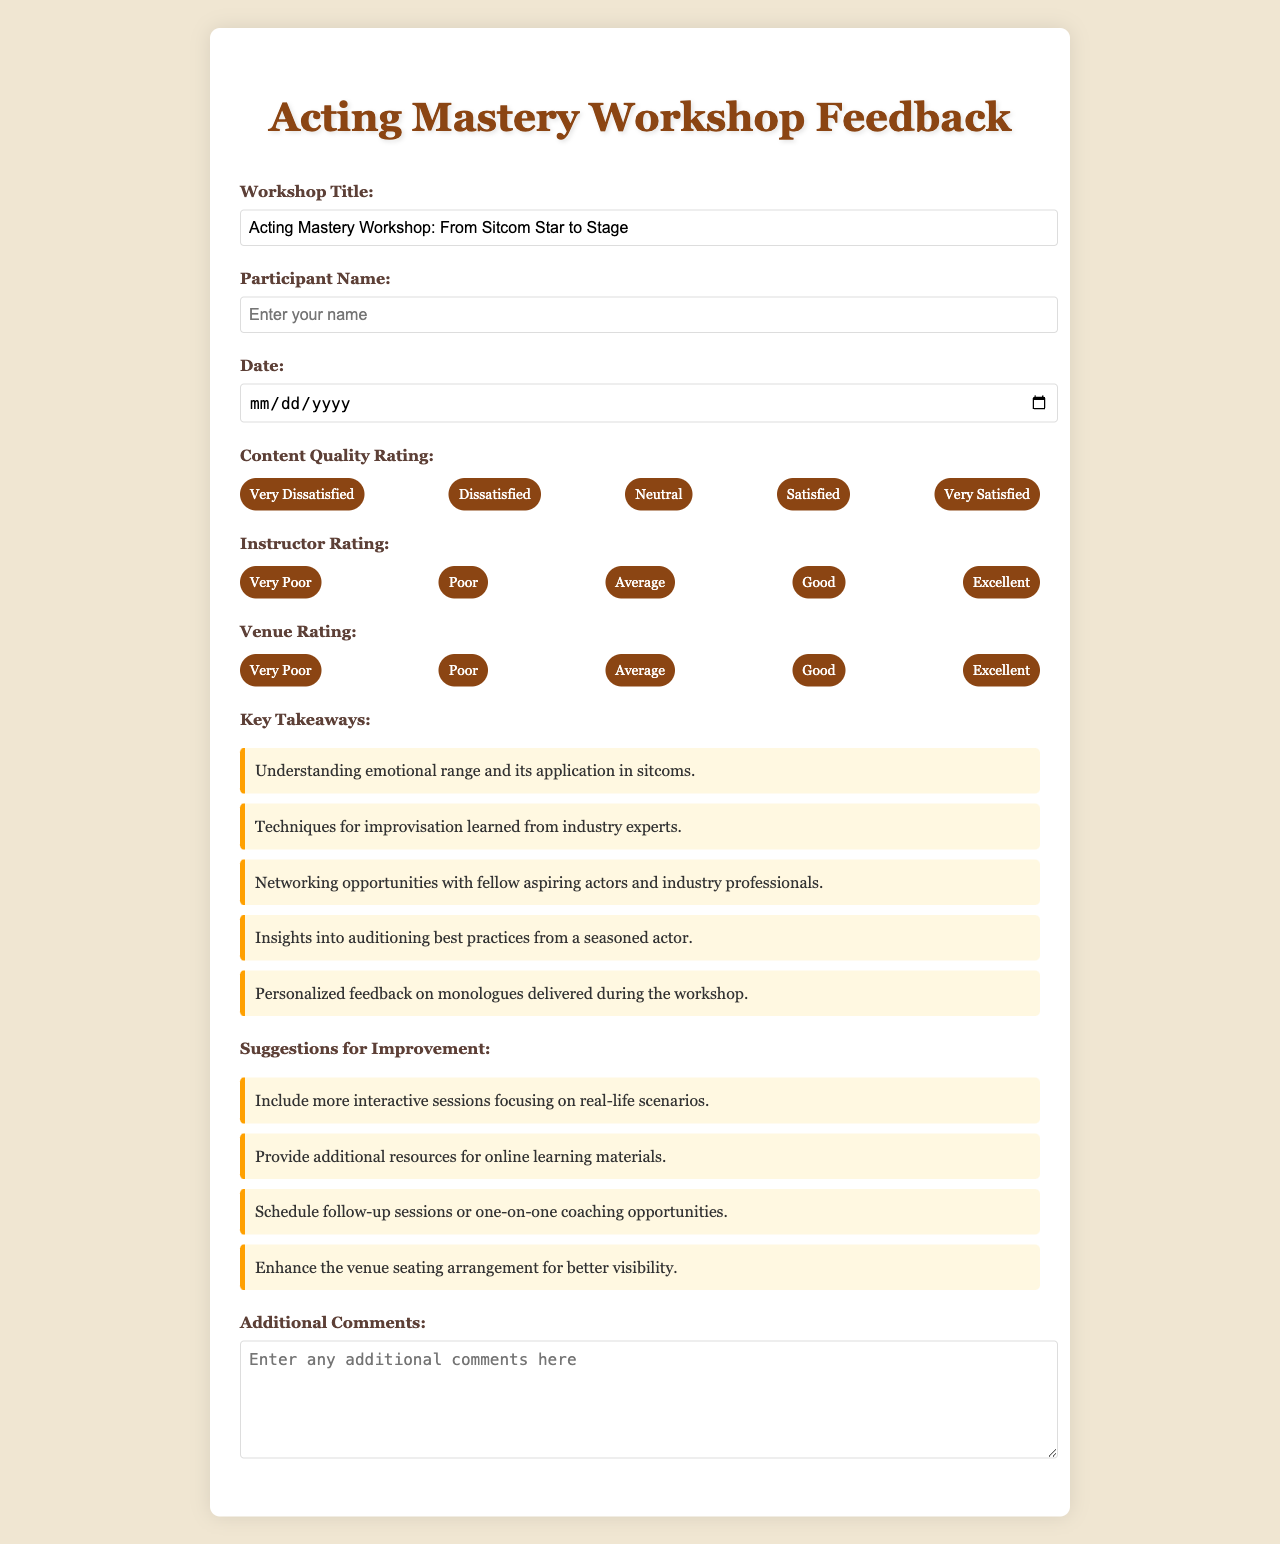What is the title of the workshop? The title is provided in the document, which states "Workshop Title: Acting Mastery Workshop: From Sitcom Star to Stage".
Answer: Acting Mastery Workshop: From Sitcom Star to Stage What is the main topic of the key takeaways? The key takeaways are listed in a section focused on insights gained from the workshop, including various skills and networking.
Answer: Understanding emotional range and its application in sitcoms How many suggestions for improvement are provided? The number of suggestions can be counted in the document, which lists four distinct ideas for improvement.
Answer: Four What rating is given for the content quality? There is a section titled "Content Quality Rating" with multiple options indicating the satisfaction level, but no specific rating is provided in the text.
Answer: Not specified What is the date field in the form used for? The date field is included in the form for participants to input when they attended the workshop.
Answer: Date of participation Who is the instructor rating for? The instructor rating section pertains to the quality of the teaching during the workshop, evaluating the instructor’s performance.
Answer: Not specified What is one suggestion for improvement? A list is provided suggesting ways to enhance the workshop, and participants can see numerous recommendations in the document.
Answer: Include more interactive sessions focusing on real-life scenarios How is the venue rated? A separate section is designated for assessing the venue, indicating the quality of the location where the workshop took place.
Answer: Not specified What type of feedback does the form collect? The feedback form is designed to collect evaluations on various aspects like content quality, instructor performance, and other suggestions.
Answer: Participant satisfaction 